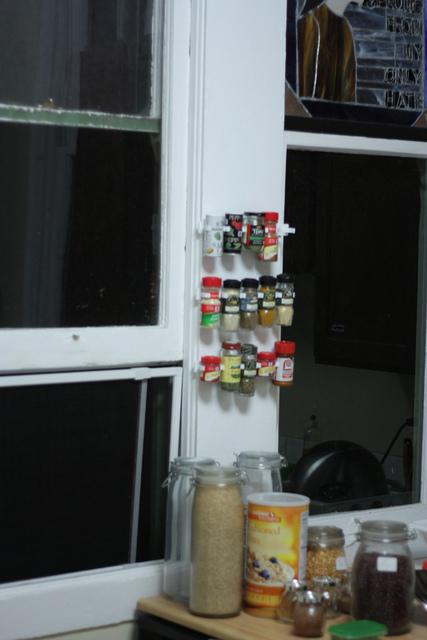What small appliance is on the bottom shelf?
Write a very short answer. Toaster. Is it daytime?
Be succinct. No. What type of nuts are in the jar?
Be succinct. Peanuts. Is there something on top of the jar?
Write a very short answer. No. What is drawn on the glass?
Give a very brief answer. Nothing. What is the counter made of?
Be succinct. Wood. Is the front shelf a new item or a used item?
Concise answer only. Used. How many jars are there?
Short answer required. 5. Is the window open?
Keep it brief. No. What is in the bottle with the red label?
Quick response, please. Spices. What kind of room is this?
Give a very brief answer. Kitchen. What color is the coffee cup?
Give a very brief answer. White. Can you see through this window?
Write a very short answer. Yes. How many windows do you see?
Keep it brief. 2. What is on the wall?
Quick response, please. Spices. 